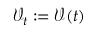Convert formula to latex. <formula><loc_0><loc_0><loc_500><loc_500>\mathcal { V } _ { t } \colon = \mathcal { V } ( t )</formula> 